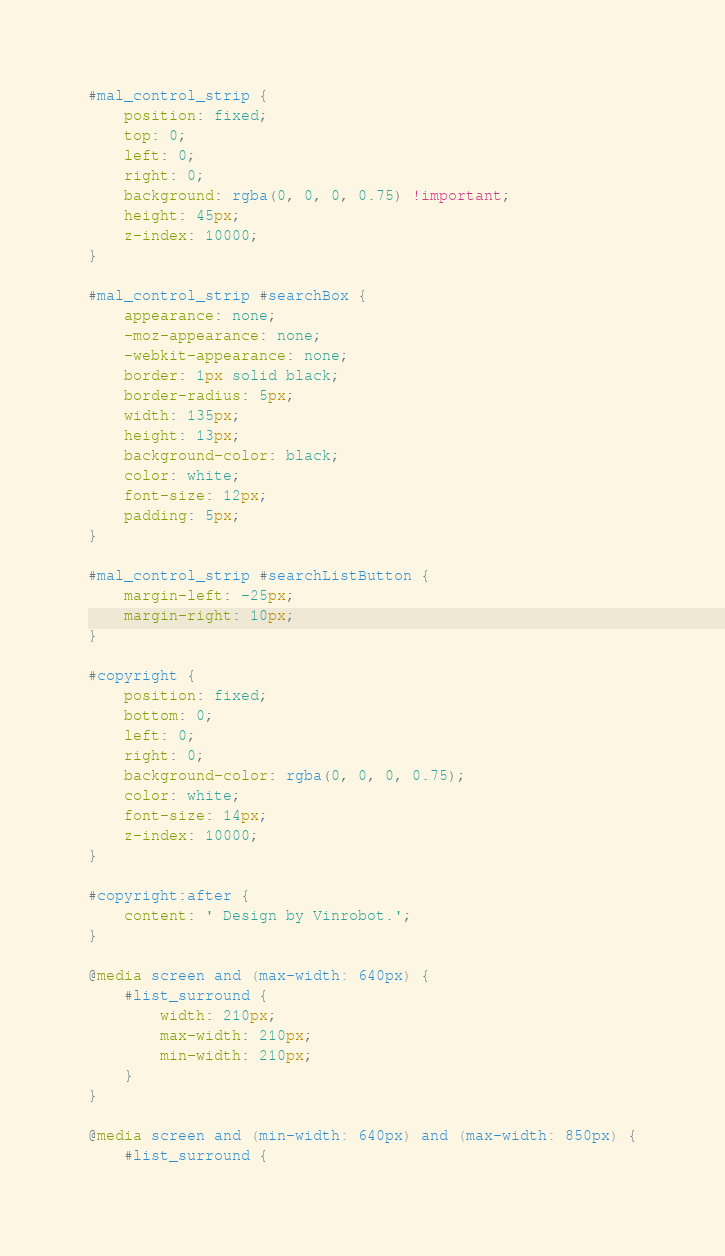Convert code to text. <code><loc_0><loc_0><loc_500><loc_500><_CSS_>#mal_control_strip {
	position: fixed;
	top: 0;
	left: 0;
	right: 0;
	background: rgba(0, 0, 0, 0.75) !important;
	height: 45px;
	z-index: 10000;
}

#mal_control_strip #searchBox {
	appearance: none;
	-moz-appearance: none;
	-webkit-appearance: none;
	border: 1px solid black;
	border-radius: 5px;
	width: 135px;
	height: 13px;
	background-color: black;
	color: white;
	font-size: 12px;
	padding: 5px;
}

#mal_control_strip #searchListButton {
	margin-left: -25px;
	margin-right: 10px;
}

#copyright {
	position: fixed;
	bottom: 0;
	left: 0;
	right: 0;
	background-color: rgba(0, 0, 0, 0.75);
	color: white;
	font-size: 14px;
	z-index: 10000;
}

#copyright:after {
	content: ' Design by Vinrobot.';
}

@media screen and (max-width: 640px) {
	#list_surround {
		width: 210px;
		max-width: 210px;
		min-width: 210px;
	}
}

@media screen and (min-width: 640px) and (max-width: 850px) {
	#list_surround {</code> 